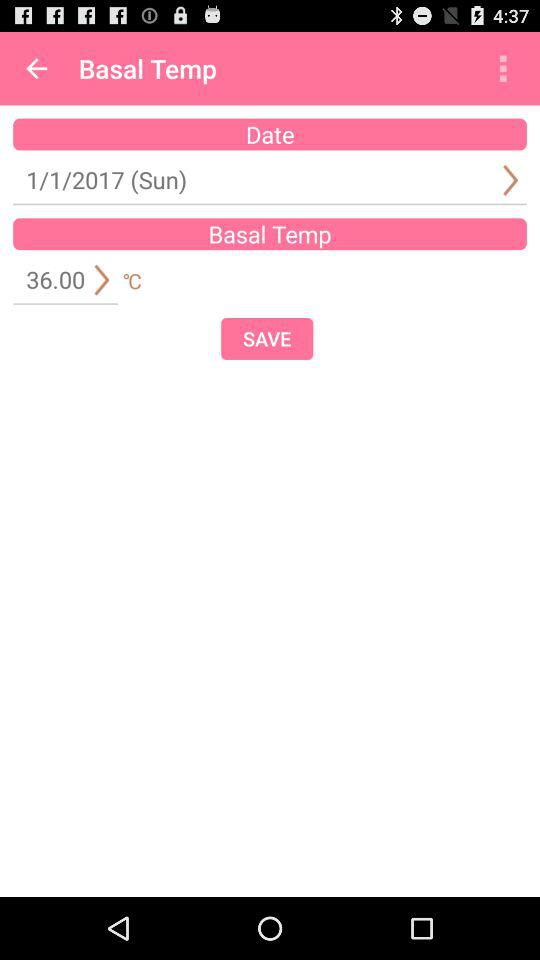What's the basal temperature? The basal temperature is 36 °C. 